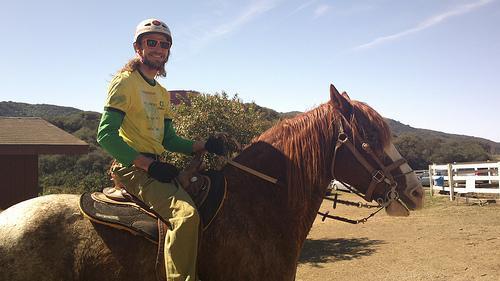How many people are pictured here?
Give a very brief answer. 1. 